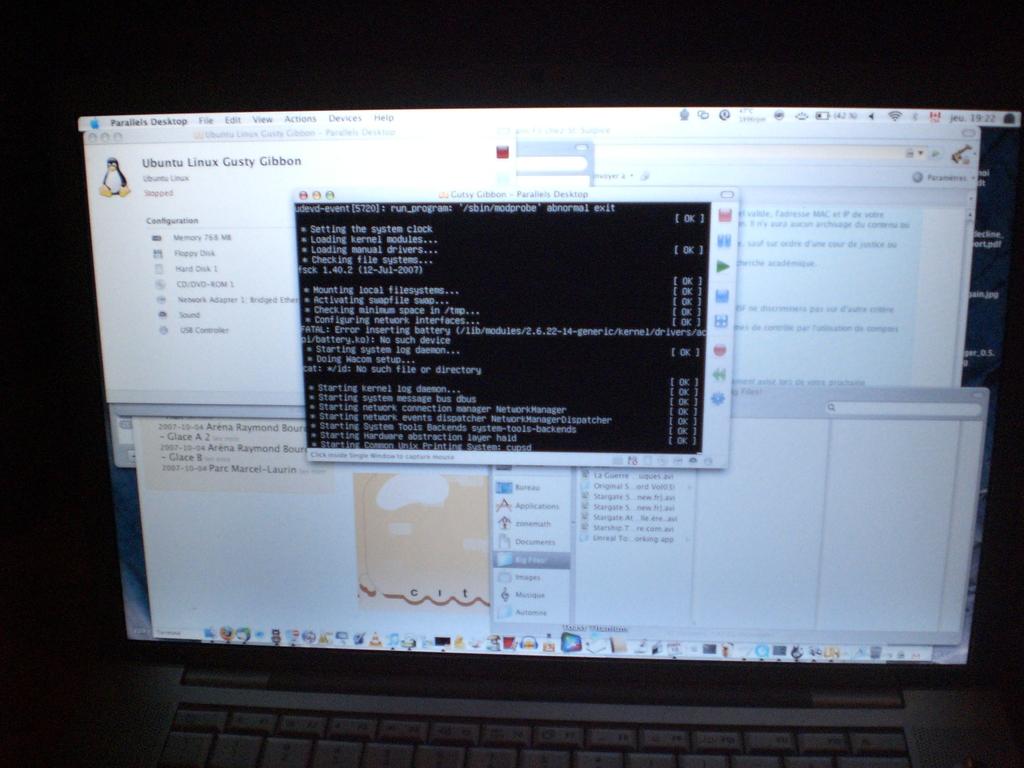What is the title of the application next to the penguin?
Offer a terse response. Ubuntu linux gusty gibbon. 